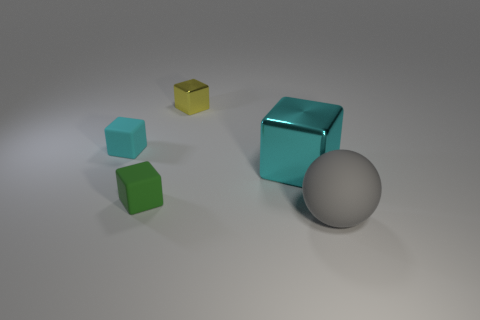Is there any other thing that is the same material as the small yellow object?
Give a very brief answer. Yes. How many things are shiny blocks that are behind the big cyan metallic cube or rubber objects that are behind the gray rubber sphere?
Make the answer very short. 3. Is the tiny green object made of the same material as the object behind the cyan matte thing?
Give a very brief answer. No. What shape is the matte thing that is in front of the tiny cyan thing and on the left side of the gray matte ball?
Give a very brief answer. Cube. How many other objects are there of the same color as the ball?
Give a very brief answer. 0. What shape is the big metallic object?
Keep it short and to the point. Cube. There is a large thing that is in front of the large object that is behind the gray rubber object; what is its color?
Offer a very short reply. Gray. Do the big rubber sphere and the shiny object that is to the right of the small yellow cube have the same color?
Your response must be concise. No. The cube that is in front of the yellow metal block and to the right of the green thing is made of what material?
Your answer should be compact. Metal. Are there any yellow objects of the same size as the cyan metal thing?
Your response must be concise. No. 